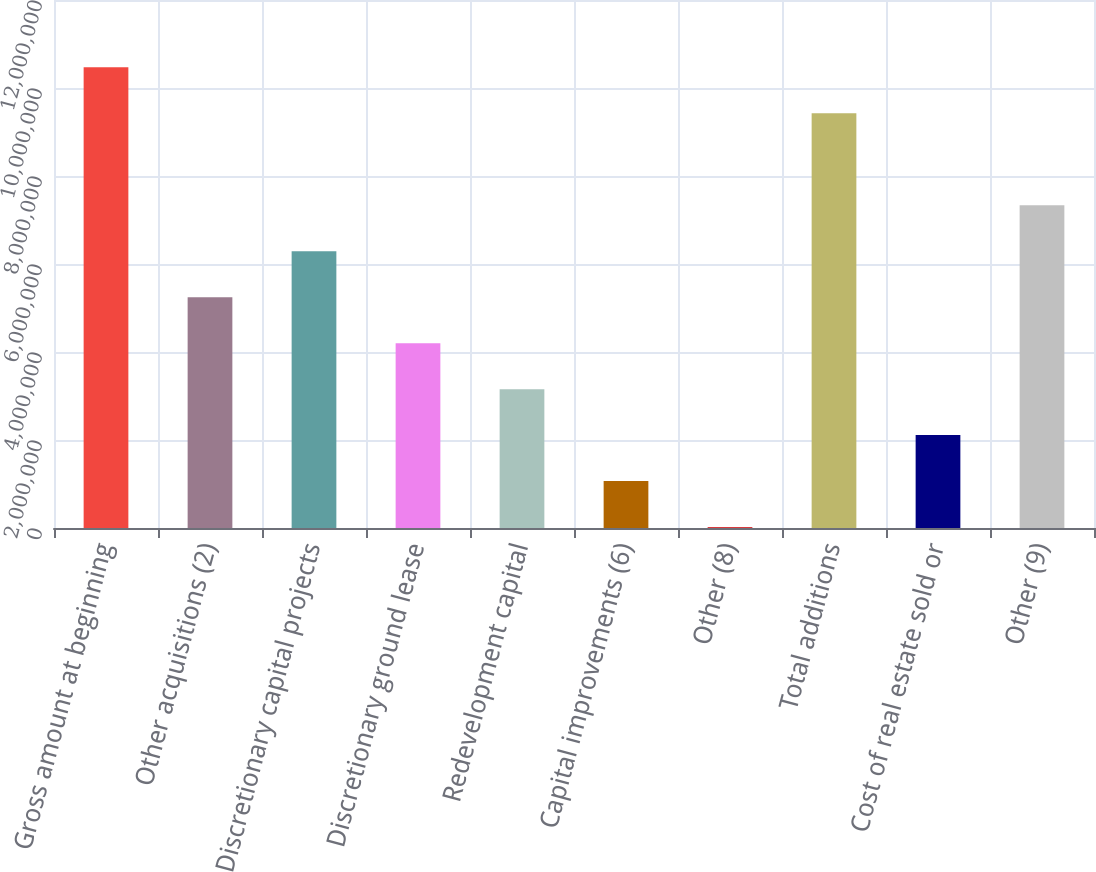Convert chart. <chart><loc_0><loc_0><loc_500><loc_500><bar_chart><fcel>Gross amount at beginning<fcel>Other acquisitions (2)<fcel>Discretionary capital projects<fcel>Discretionary ground lease<fcel>Redevelopment capital<fcel>Capital improvements (6)<fcel>Other (8)<fcel>Total additions<fcel>Cost of real estate sold or<fcel>Other (9)<nl><fcel>1.04692e+07<fcel>5.24564e+06<fcel>6.29035e+06<fcel>4.20092e+06<fcel>3.15621e+06<fcel>1.06678e+06<fcel>22069<fcel>9.42449e+06<fcel>2.1115e+06<fcel>7.33507e+06<nl></chart> 